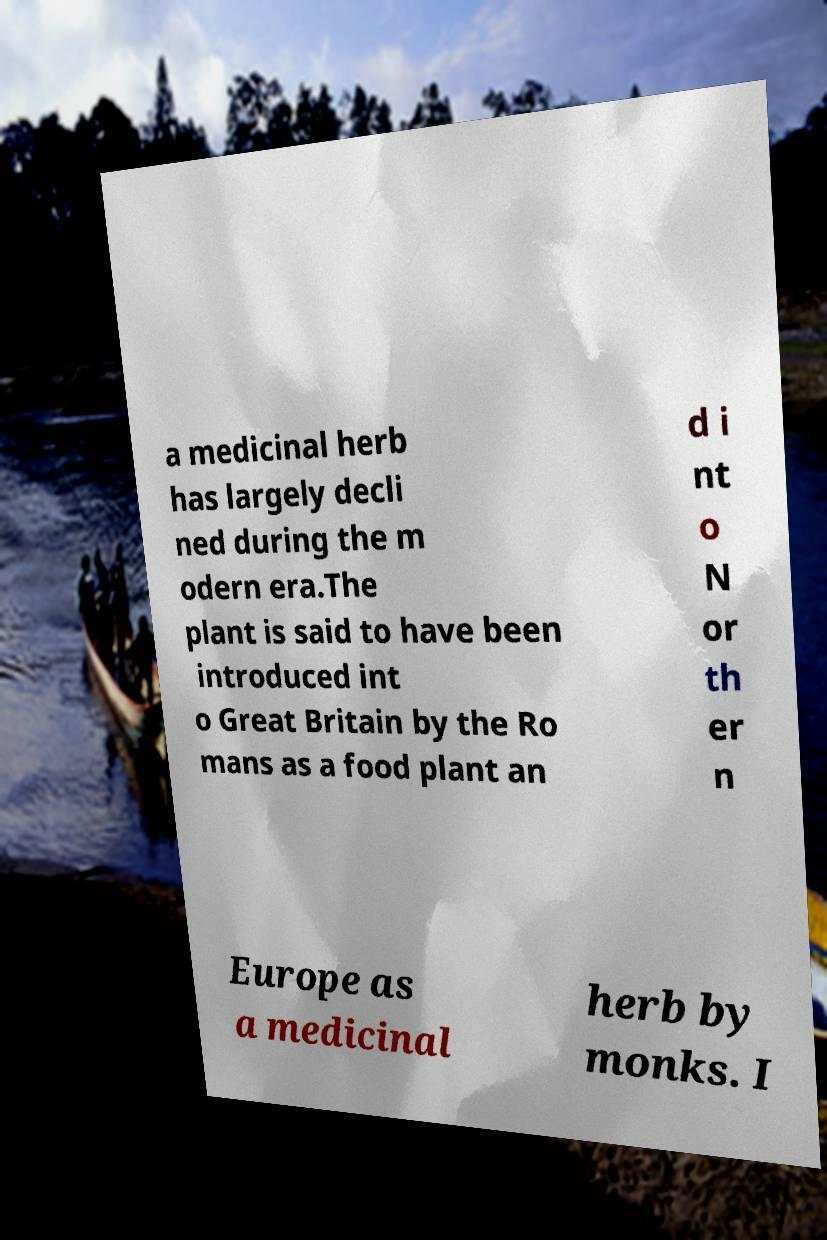Can you accurately transcribe the text from the provided image for me? a medicinal herb has largely decli ned during the m odern era.The plant is said to have been introduced int o Great Britain by the Ro mans as a food plant an d i nt o N or th er n Europe as a medicinal herb by monks. I 